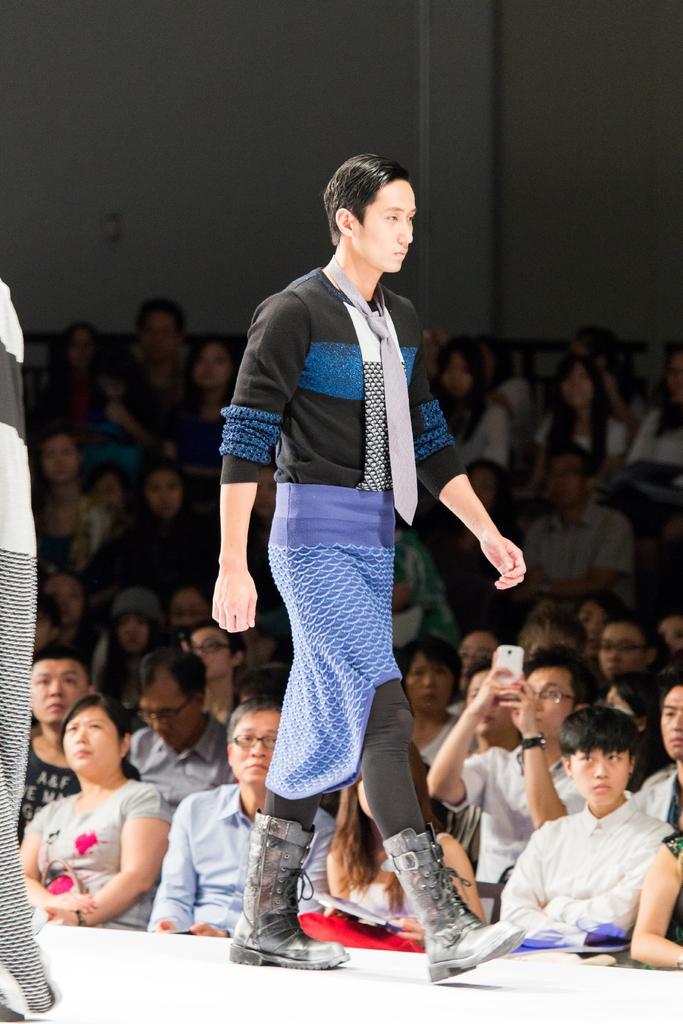Describe this image in one or two sentences. In this image there is a person walking on the stage beside the stage there are so many people sitting on chairs and watching at them also there is a man holding camera and capturing. 